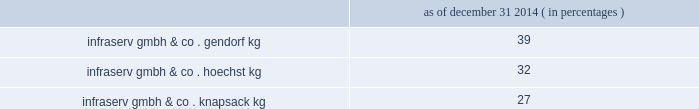Fortron industries llc .
Fortron is a leading global producer of pps , sold under the fortron ae brand , which is used in a wide variety of automotive and other applications , especially those requiring heat and/or chemical resistance .
Fortron's facility is located in wilmington , north carolina .
This venture combines the sales , marketing , distribution , compounding and manufacturing expertise of celanese with the pps polymer technology expertise of kureha america inc .
Cellulose derivatives strategic ventures .
Our cellulose derivatives ventures generally fund their operations using operating cash flow and pay dividends based on each ventures' performance in the preceding year .
In 2014 , 2013 and 2012 , we received cash dividends of $ 115 million , $ 92 million and $ 83 million , respectively .
Although our ownership interest in each of our cellulose derivatives ventures exceeds 20% ( 20 % ) , we account for these investments using the cost method of accounting because we determined that we cannot exercise significant influence over these entities due to local government investment in and influence over these entities , limitations on our involvement in the day-to-day operations and the present inability of the entities to provide timely financial information prepared in accordance with generally accepted accounting principles in the united states of america ( "us gaap" ) .
2022 other equity method investments infraservs .
We hold indirect ownership interests in several german infraserv groups that own and develop industrial parks and provide on-site general and administrative support to tenants .
Our ownership interest in the equity investments in infraserv affiliates are as follows : as of december 31 , 2014 ( in percentages ) .
Research and development our businesses are innovation-oriented and conduct research and development activities to develop new , and optimize existing , production technologies , as well as to develop commercially viable new products and applications .
Research and development expense was $ 86 million , $ 85 million and $ 104 million for the years ended december 31 , 2014 , 2013 and 2012 , respectively .
We consider the amounts spent during each of the last three fiscal years on research and development activities to be sufficient to execute our current strategic initiatives .
Intellectual property we attach importance to protecting our intellectual property , including safeguarding our confidential information and through our patents , trademarks and copyrights , in order to preserve our investment in research and development , manufacturing and marketing .
Patents may cover processes , equipment , products , intermediate products and product uses .
We also seek to register trademarks as a means of protecting the brand names of our company and products .
Patents .
In most industrial countries , patent protection exists for new substances and formulations , as well as for certain unique applications and production processes .
However , we do business in regions of the world where intellectual property protection may be limited and difficult to enforce .
Confidential information .
We maintain stringent information security policies and procedures wherever we do business .
Such information security policies and procedures include data encryption , controls over the disclosure and safekeeping of confidential information and trade secrets , as well as employee awareness training .
Trademarks .
Aoplus ae , aoplus ae2 , aoplus ae3 , ateva ae , avicor ae , britecoat ae , celanese ae , celanex ae , celcon ae , celfx 2122 , celstran ae , celvolit ae , clarifoil ae , duroset ae , ecovae ae , factor ae , fortron ae , gur ae , hostaform ae , impet ae , mowilith ae , nutrinova ae , qorus 2122 , riteflex ae , sunett ae , tcx 2122 , thermx ae , tufcor ae , vantage ae , vantageplus 2122 , vantage ae2 , vectra ae , vinamul ae , vitaldose ae , zenite ae and certain other branded products and services named in this document are registered or reserved trademarks or service marks owned or licensed by celanese .
The foregoing is not intended to be an exhaustive or comprehensive list of all registered or reserved trademarks and service marks owned or licensed by celanese .
Fortron ae is a registered trademark of fortron industries llc. .
What is the ratio of the cash dividend to the research and development in 2014? 
Rationale: in 2014 every dollar invested in r&d returned 1.3 in cash dividends
Computations: (115 / 86)
Answer: 1.33721. 